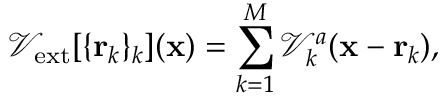<formula> <loc_0><loc_0><loc_500><loc_500>\mathcal { V } _ { e x t } [ \{ { r } _ { k } \} _ { k } ] ( { x } ) = \sum _ { k = 1 } ^ { M } { \mathcal { V } _ { k } ^ { a } ( { x } - { r } _ { k } ) } ,</formula> 